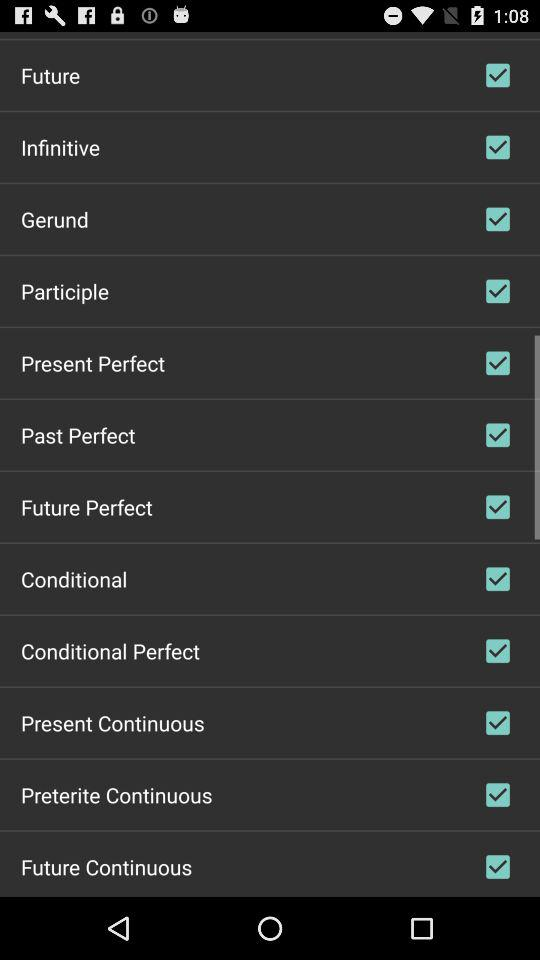What is the status of "Past Perfect"? The status is "on". 